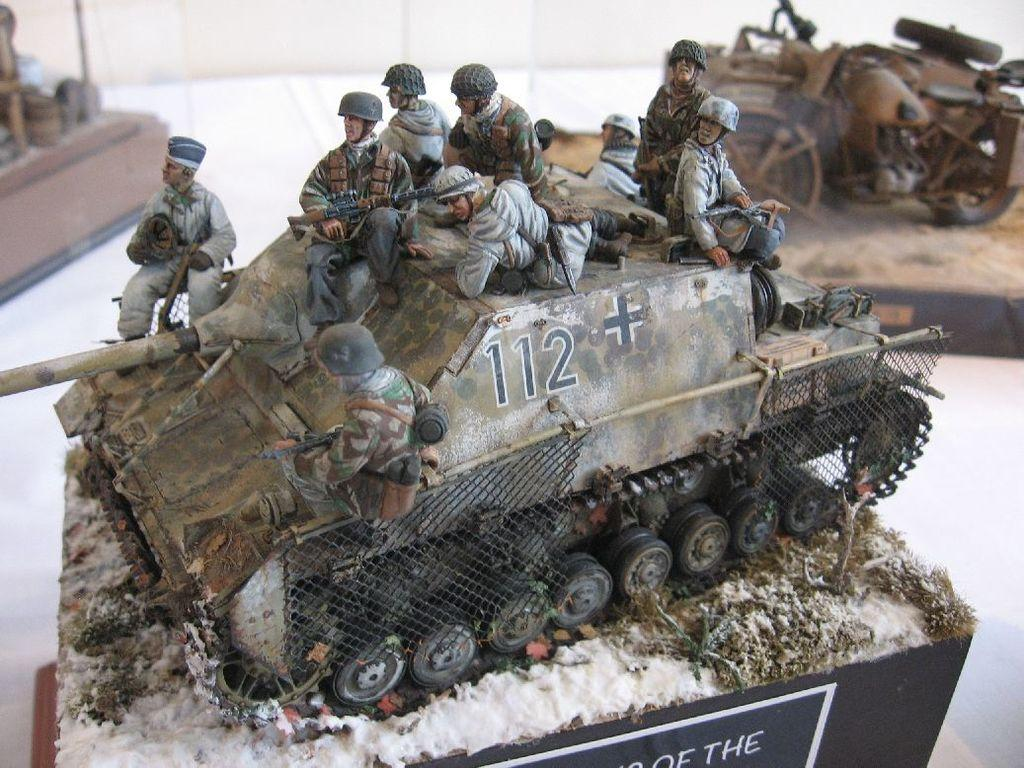What is the main subject of the image? The main subject of the image is a military tank. What other items can be seen in the image? There are vehicle models and persons models in the image. Is there any information provided about the items in the image? Yes, there is a description board in the image. What type of attraction is the spoon involved in within the image? There is no spoon present in the image, so it cannot be involved in any attraction. 